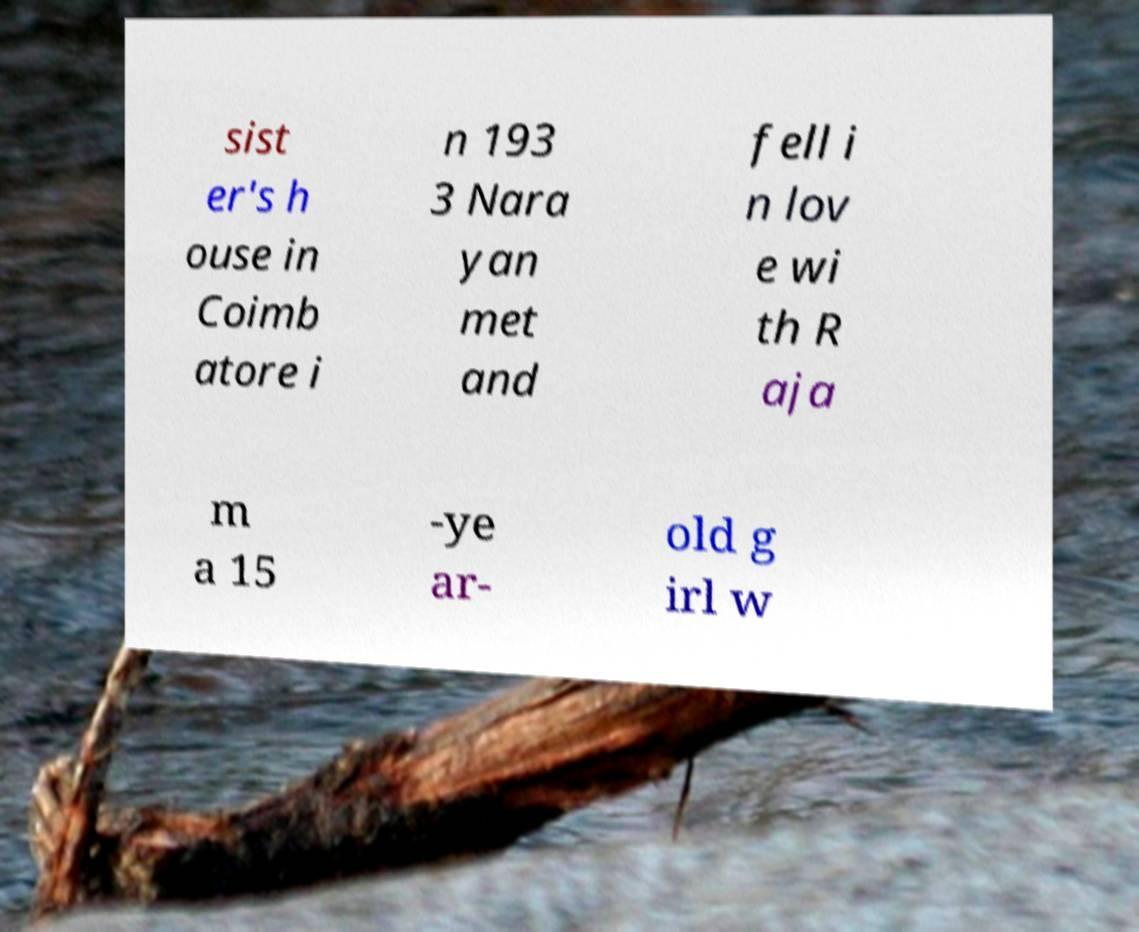I need the written content from this picture converted into text. Can you do that? sist er's h ouse in Coimb atore i n 193 3 Nara yan met and fell i n lov e wi th R aja m a 15 -ye ar- old g irl w 